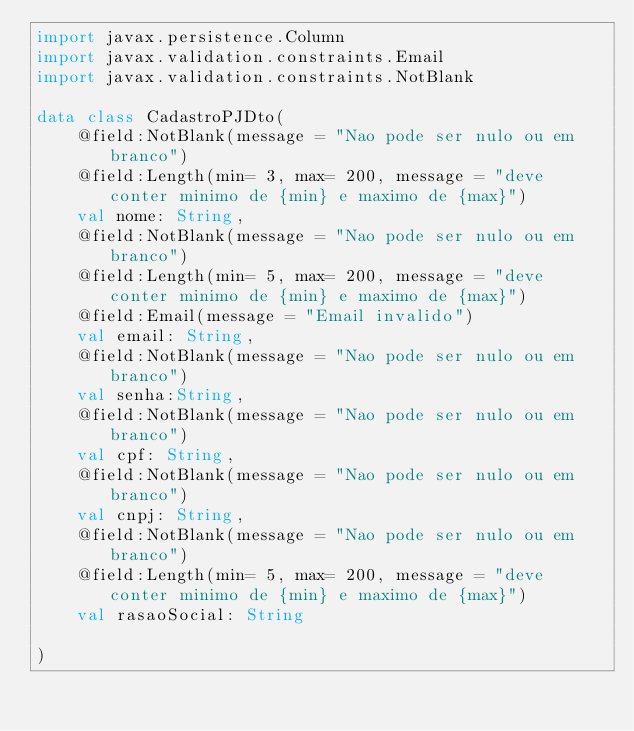<code> <loc_0><loc_0><loc_500><loc_500><_Kotlin_>import javax.persistence.Column
import javax.validation.constraints.Email
import javax.validation.constraints.NotBlank

data class CadastroPJDto(
    @field:NotBlank(message = "Nao pode ser nulo ou em branco")
    @field:Length(min= 3, max= 200, message = "deve conter minimo de {min} e maximo de {max}")
    val nome: String,
    @field:NotBlank(message = "Nao pode ser nulo ou em branco")
    @field:Length(min= 5, max= 200, message = "deve conter minimo de {min} e maximo de {max}")
    @field:Email(message = "Email invalido")
    val email: String,
    @field:NotBlank(message = "Nao pode ser nulo ou em branco")
    val senha:String,
    @field:NotBlank(message = "Nao pode ser nulo ou em branco")
    val cpf: String,
    @field:NotBlank(message = "Nao pode ser nulo ou em branco")
    val cnpj: String,
    @field:NotBlank(message = "Nao pode ser nulo ou em branco")
    @field:Length(min= 5, max= 200, message = "deve conter minimo de {min} e maximo de {max}")
    val rasaoSocial: String

)
</code> 